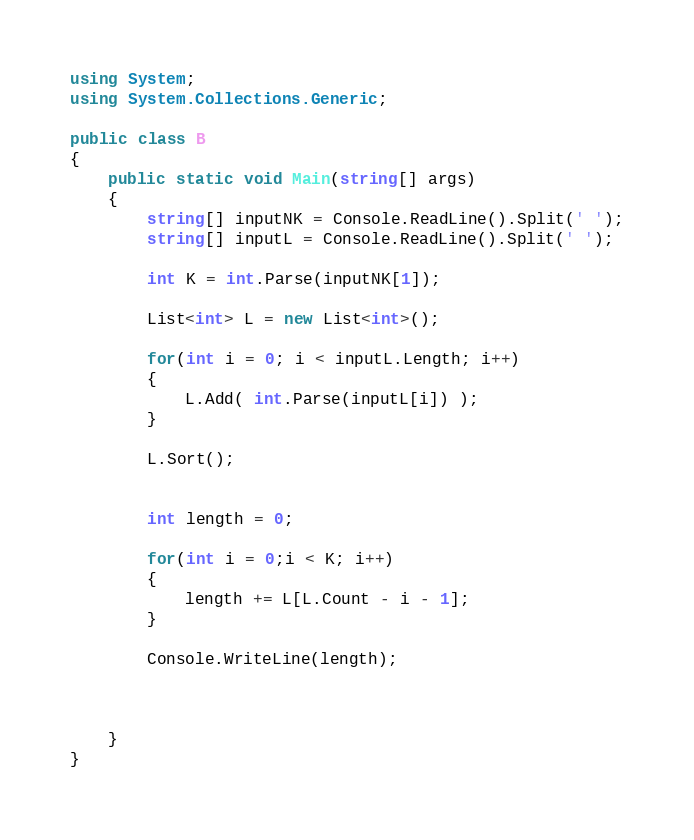<code> <loc_0><loc_0><loc_500><loc_500><_C#_>using System;
using System.Collections.Generic;

public class B
{
	public static void Main(string[] args)
	{
        string[] inputNK = Console.ReadLine().Split(' ');
        string[] inputL = Console.ReadLine().Split(' ');

        int K = int.Parse(inputNK[1]);

        List<int> L = new List<int>();

        for(int i = 0; i < inputL.Length; i++)
        {
            L.Add( int.Parse(inputL[i]) );
        }

        L.Sort();


        int length = 0;

        for(int i = 0;i < K; i++)
        {
            length += L[L.Count - i - 1];
        }

        Console.WriteLine(length);



	}
}
</code> 